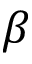<formula> <loc_0><loc_0><loc_500><loc_500>\beta</formula> 